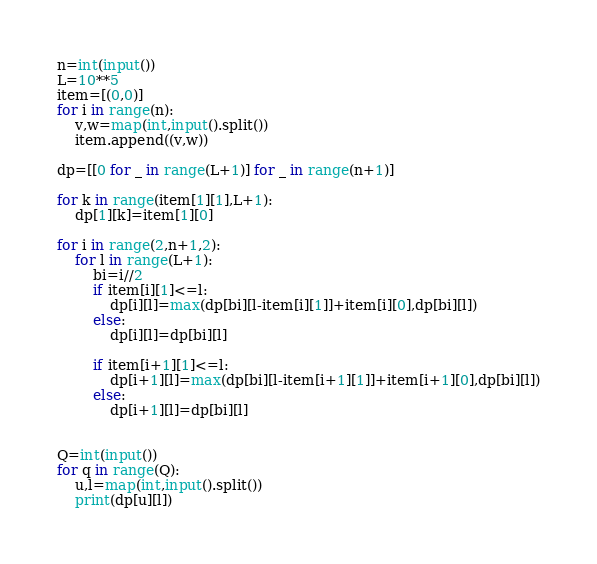<code> <loc_0><loc_0><loc_500><loc_500><_Python_>n=int(input())
L=10**5
item=[(0,0)]
for i in range(n):
    v,w=map(int,input().split())
    item.append((v,w))

dp=[[0 for _ in range(L+1)] for _ in range(n+1)] 

for k in range(item[1][1],L+1):
    dp[1][k]=item[1][0]
    
for i in range(2,n+1,2):
    for l in range(L+1):
        bi=i//2
        if item[i][1]<=l:
            dp[i][l]=max(dp[bi][l-item[i][1]]+item[i][0],dp[bi][l])
        else:
            dp[i][l]=dp[bi][l]

        if item[i+1][1]<=l:
            dp[i+1][l]=max(dp[bi][l-item[i+1][1]]+item[i+1][0],dp[bi][l])
        else:
            dp[i+1][l]=dp[bi][l]
        

Q=int(input())
for q in range(Q):
    u,l=map(int,input().split())
    print(dp[u][l])        </code> 